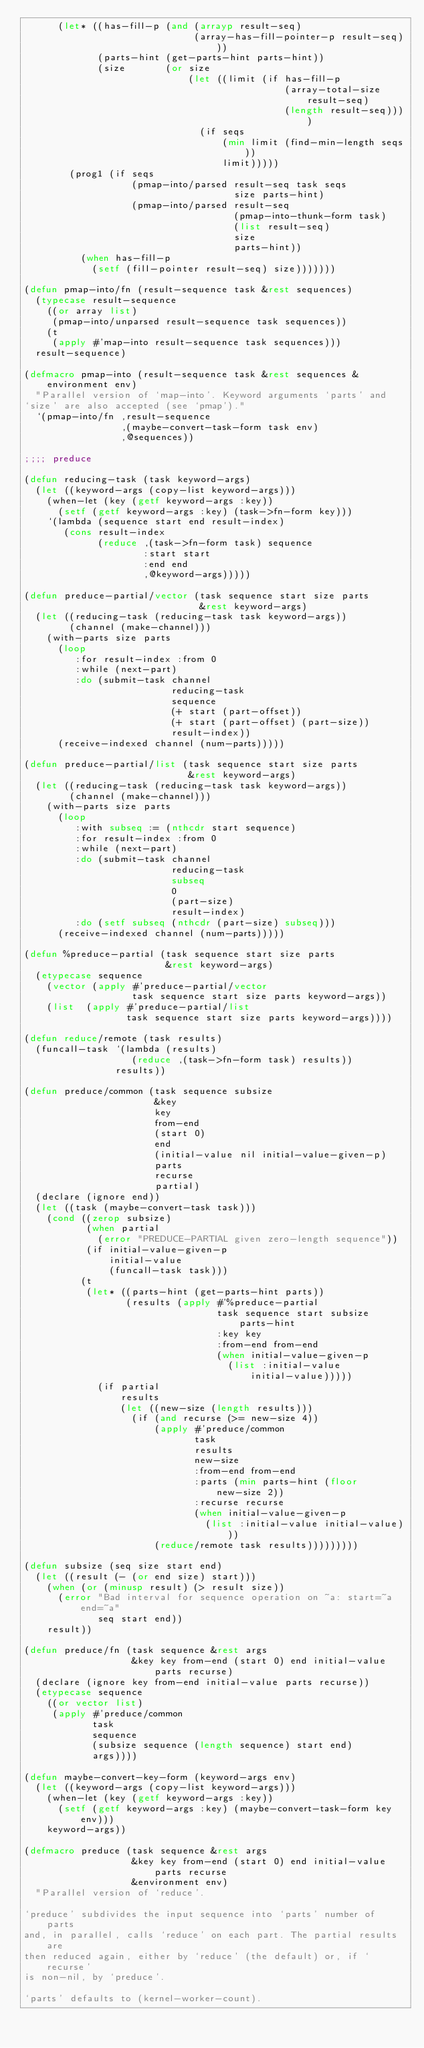<code> <loc_0><loc_0><loc_500><loc_500><_Lisp_>      (let* ((has-fill-p (and (arrayp result-seq)
                              (array-has-fill-pointer-p result-seq)))
             (parts-hint (get-parts-hint parts-hint))
             (size       (or size
                             (let ((limit (if has-fill-p
                                              (array-total-size result-seq)
                                              (length result-seq))))
                               (if seqs
                                   (min limit (find-min-length seqs))
                                   limit)))))
        (prog1 (if seqs
                   (pmap-into/parsed result-seq task seqs
                                     size parts-hint)
                   (pmap-into/parsed result-seq
                                     (pmap-into-thunk-form task)
                                     (list result-seq)
                                     size
                                     parts-hint))
          (when has-fill-p
            (setf (fill-pointer result-seq) size)))))))

(defun pmap-into/fn (result-sequence task &rest sequences)
  (typecase result-sequence
    ((or array list)
     (pmap-into/unparsed result-sequence task sequences))
    (t
     (apply #'map-into result-sequence task sequences)))
  result-sequence)

(defmacro pmap-into (result-sequence task &rest sequences &environment env)
  "Parallel version of `map-into'. Keyword arguments `parts' and
`size' are also accepted (see `pmap')."
  `(pmap-into/fn ,result-sequence
                 ,(maybe-convert-task-form task env)
                 ,@sequences))

;;;; preduce

(defun reducing-task (task keyword-args)
  (let ((keyword-args (copy-list keyword-args)))
    (when-let (key (getf keyword-args :key))
      (setf (getf keyword-args :key) (task->fn-form key)))
    `(lambda (sequence start end result-index)
       (cons result-index
             (reduce ,(task->fn-form task) sequence
                     :start start
                     :end end
                     ,@keyword-args)))))

(defun preduce-partial/vector (task sequence start size parts
                               &rest keyword-args)
  (let ((reducing-task (reducing-task task keyword-args))
        (channel (make-channel)))
    (with-parts size parts
      (loop
         :for result-index :from 0
         :while (next-part)
         :do (submit-task channel
                          reducing-task
                          sequence
                          (+ start (part-offset))
                          (+ start (part-offset) (part-size))
                          result-index))
      (receive-indexed channel (num-parts)))))

(defun preduce-partial/list (task sequence start size parts
                             &rest keyword-args)
  (let ((reducing-task (reducing-task task keyword-args))
        (channel (make-channel)))
    (with-parts size parts
      (loop
         :with subseq := (nthcdr start sequence)
         :for result-index :from 0
         :while (next-part)
         :do (submit-task channel
                          reducing-task
                          subseq
                          0
                          (part-size)
                          result-index)
         :do (setf subseq (nthcdr (part-size) subseq)))
      (receive-indexed channel (num-parts)))))

(defun %preduce-partial (task sequence start size parts
                         &rest keyword-args)
  (etypecase sequence
    (vector (apply #'preduce-partial/vector
                   task sequence start size parts keyword-args))
    (list  (apply #'preduce-partial/list
                  task sequence start size parts keyword-args))))

(defun reduce/remote (task results)
  (funcall-task `(lambda (results)
                   (reduce ,(task->fn-form task) results))
                results))

(defun preduce/common (task sequence subsize
                       &key
                       key
                       from-end
                       (start 0)
                       end
                       (initial-value nil initial-value-given-p)
                       parts
                       recurse
                       partial)
  (declare (ignore end))
  (let ((task (maybe-convert-task task)))
    (cond ((zerop subsize)
           (when partial
             (error "PREDUCE-PARTIAL given zero-length sequence"))
           (if initial-value-given-p
               initial-value
               (funcall-task task)))
          (t
           (let* ((parts-hint (get-parts-hint parts))
                  (results (apply #'%preduce-partial
                                  task sequence start subsize parts-hint
                                  :key key
                                  :from-end from-end
                                  (when initial-value-given-p
                                    (list :initial-value initial-value)))))
             (if partial
                 results
                 (let ((new-size (length results)))
                   (if (and recurse (>= new-size 4))
                       (apply #'preduce/common
                              task
                              results
                              new-size
                              :from-end from-end
                              :parts (min parts-hint (floor new-size 2))
                              :recurse recurse
                              (when initial-value-given-p
                                (list :initial-value initial-value)))
                       (reduce/remote task results)))))))))

(defun subsize (seq size start end)
  (let ((result (- (or end size) start)))
    (when (or (minusp result) (> result size))
      (error "Bad interval for sequence operation on ~a: start=~a end=~a"
             seq start end))
    result))

(defun preduce/fn (task sequence &rest args
                   &key key from-end (start 0) end initial-value parts recurse)
  (declare (ignore key from-end initial-value parts recurse))
  (etypecase sequence
    ((or vector list)
     (apply #'preduce/common
            task
            sequence
            (subsize sequence (length sequence) start end)
            args))))

(defun maybe-convert-key-form (keyword-args env)
  (let ((keyword-args (copy-list keyword-args)))
    (when-let (key (getf keyword-args :key))
      (setf (getf keyword-args :key) (maybe-convert-task-form key env)))
    keyword-args))

(defmacro preduce (task sequence &rest args
                   &key key from-end (start 0) end initial-value parts recurse
                   &environment env)
  "Parallel version of `reduce'.

`preduce' subdivides the input sequence into `parts' number of parts
and, in parallel, calls `reduce' on each part. The partial results are
then reduced again, either by `reduce' (the default) or, if `recurse'
is non-nil, by `preduce'.

`parts' defaults to (kernel-worker-count).
</code> 